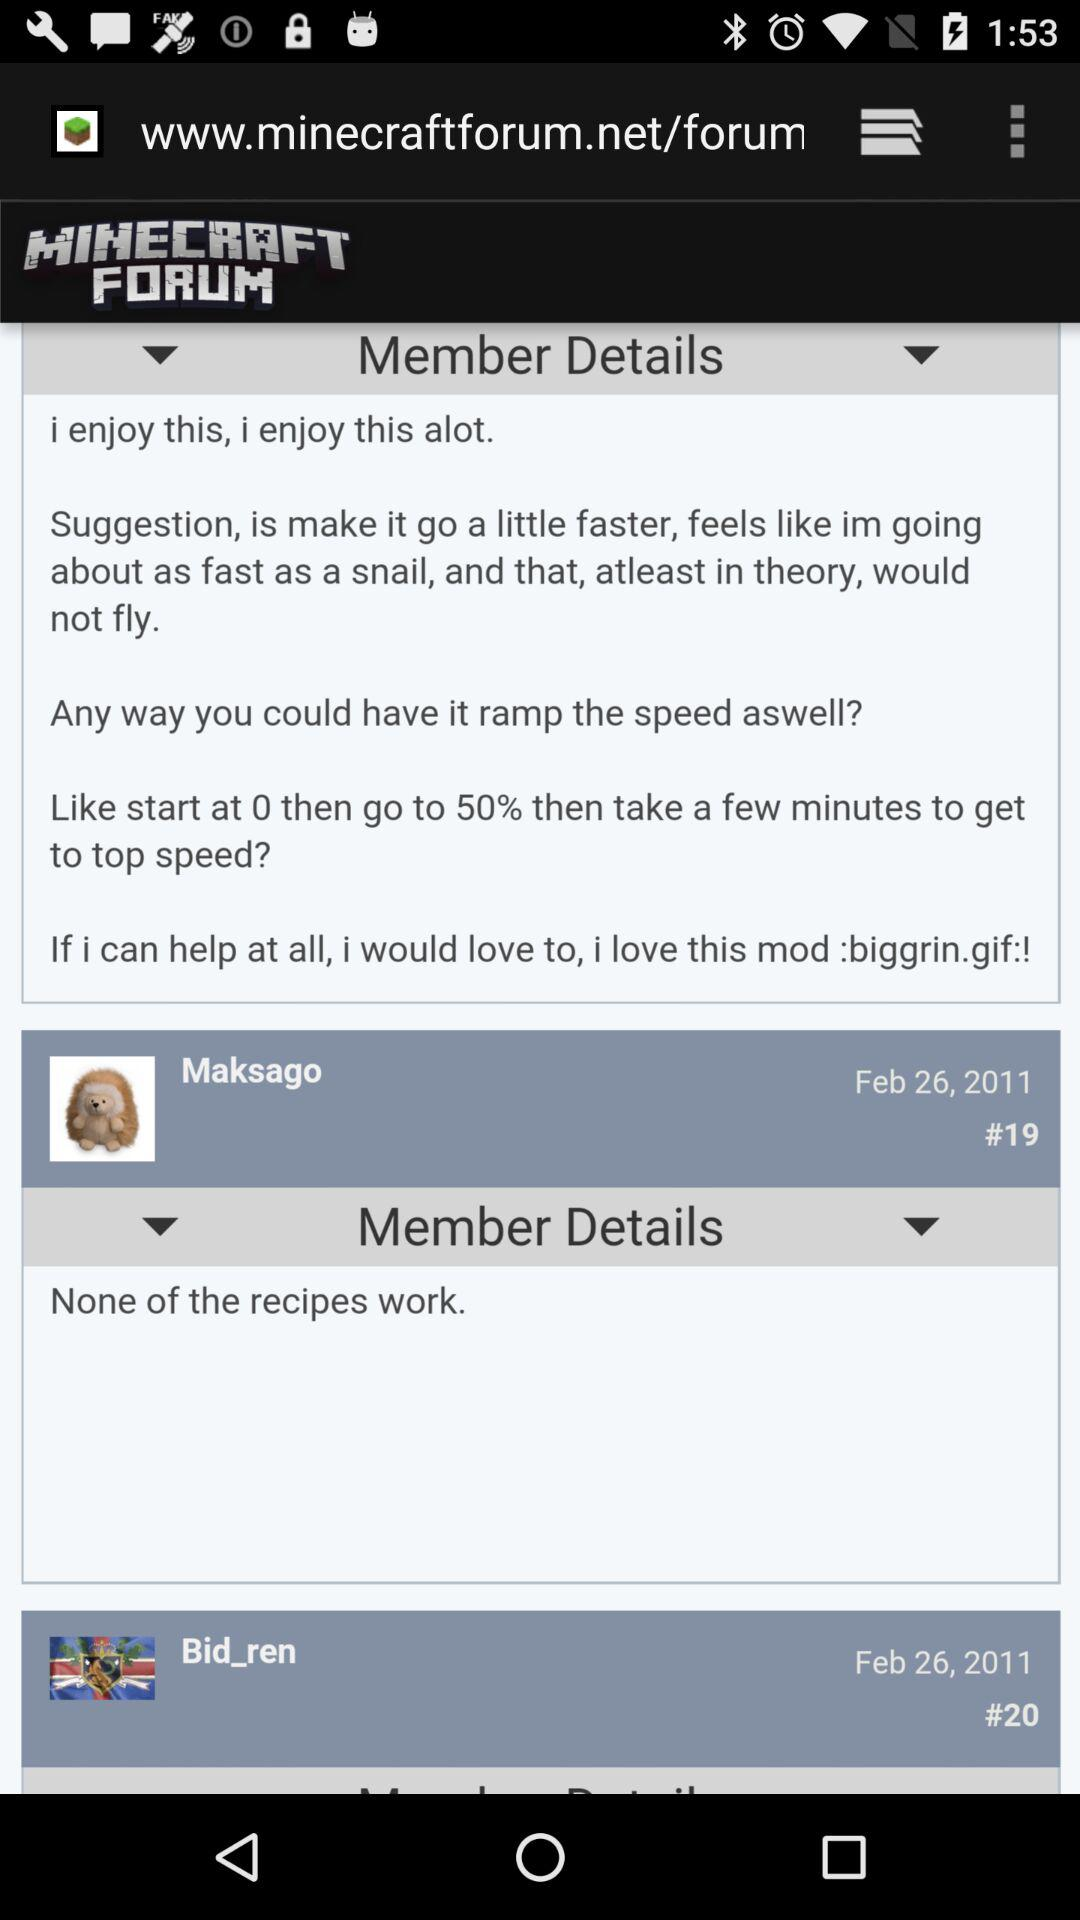On what date did "Maksago" comment? "Maksago" commented on February 26, 2011. 